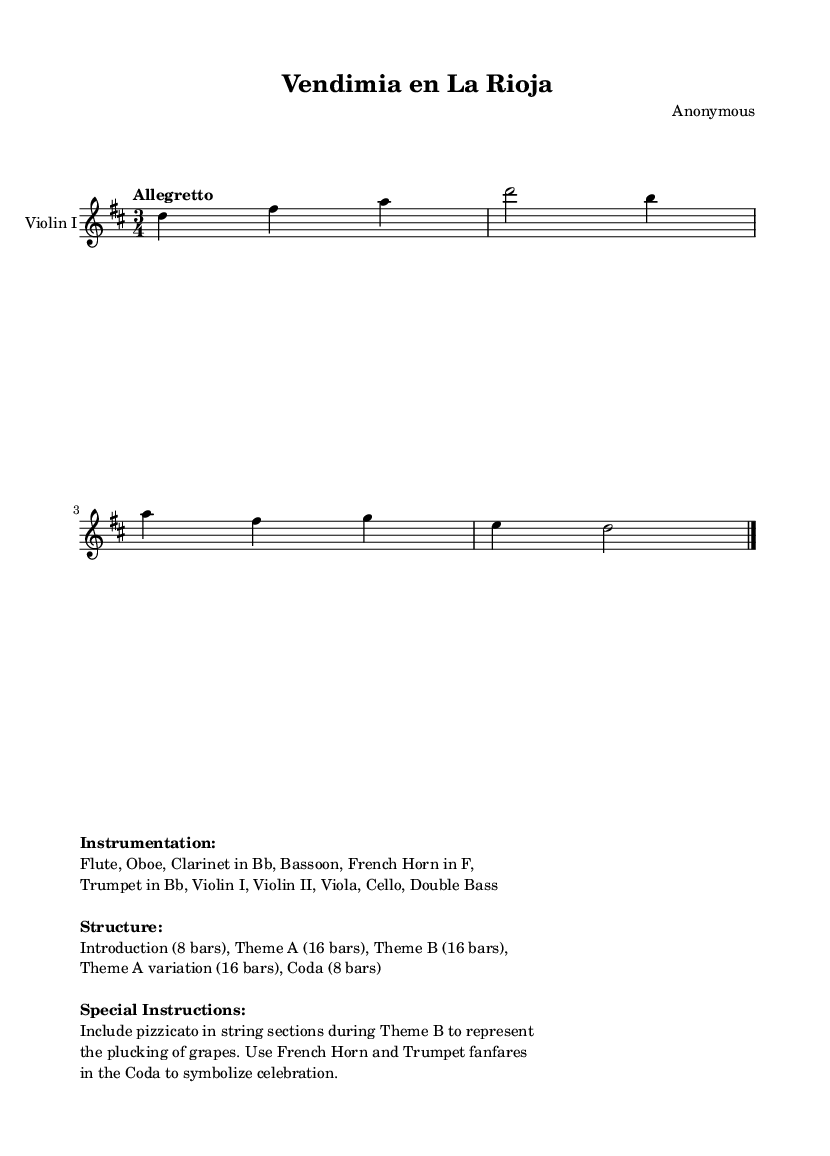What is the key signature of this music? The key signature is indicated at the beginning of the piece, showing two sharps, which corresponds to D major.
Answer: D major What is the time signature of this piece? The time signature is found at the beginning and is represented as 3/4, indicating three beats per measure.
Answer: 3/4 What is the tempo marking given in the score? The tempo marking appears below the time signature and states "Allegretto," which suggests a moderately fast pace.
Answer: Allegretto How many bars does the Introduction comprise? The structure mentioned in the markup specifies the Introduction consists of 8 bars.
Answer: 8 bars Which instruments are included in this orchestral piece? The instrumentation details in the markup list Flute, Oboe, Clarinet in Bb, Bassoon, French Horn, Trumpet in Bb, and string instruments.
Answer: Flute, Oboe, Clarinet in Bb, Bassoon, French Horn, Trumpet in Bb, Violin I, Violin II, Viola, Cello, Double Bass What unique technique is suggested during Theme B? The special instructions indicate pizzicato is to be included in the string sections during Theme B, representing the plucking of grapes.
Answer: Pizzicato What is the final section of the piece called? The structure in the markup details the final section, known as the Coda, which is 8 bars long.
Answer: Coda 